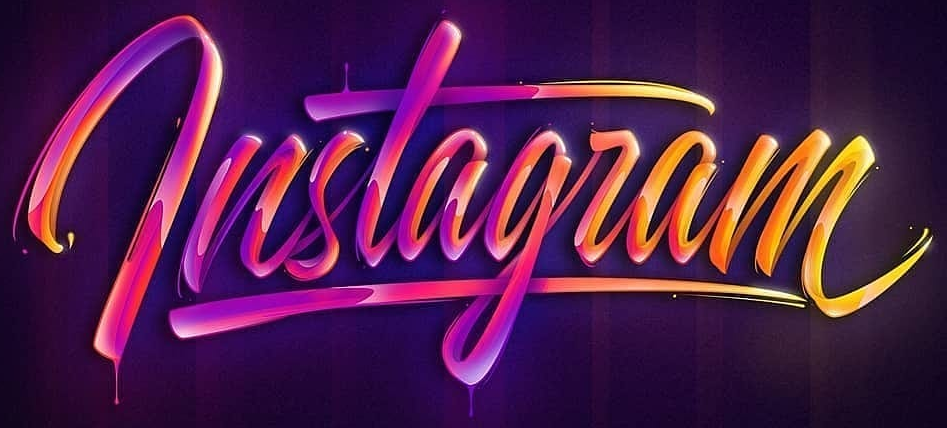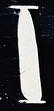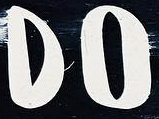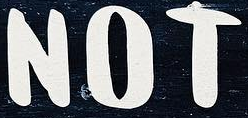Read the text from these images in sequence, separated by a semicolon. lnstagram; I; DO; NOT 